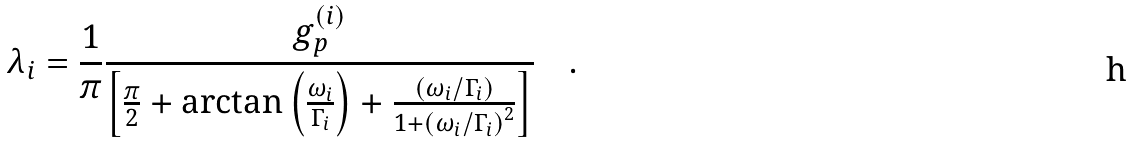<formula> <loc_0><loc_0><loc_500><loc_500>\lambda _ { i } = \frac { 1 } { \pi } \frac { g _ { p } ^ { ( i ) } } { \left [ \frac { \pi } { 2 } + \arctan \left ( \frac { \omega _ { i } } { \Gamma _ { i } } \right ) + \frac { \left ( \omega _ { i } / \Gamma _ { i } \right ) } { 1 + \left ( \omega _ { i } / \Gamma _ { i } \right ) ^ { 2 } } \right ] } \quad .</formula> 